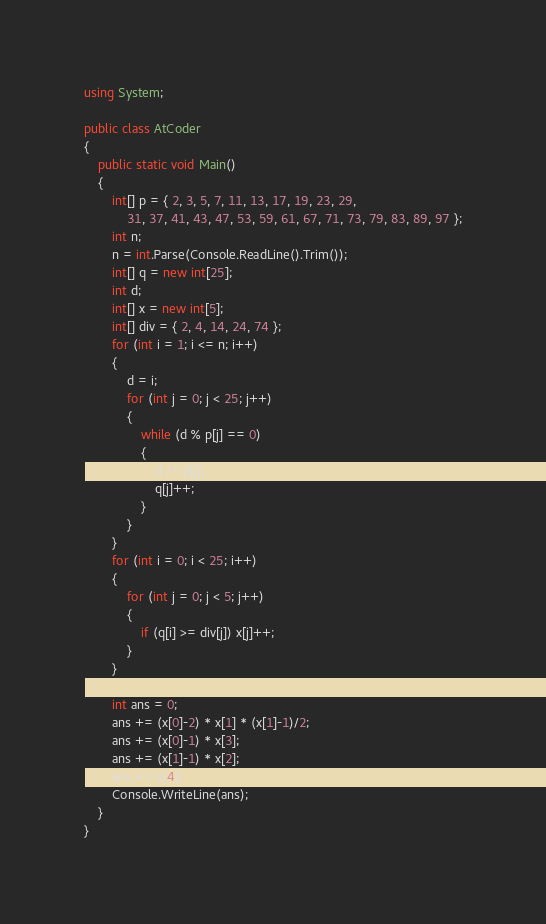<code> <loc_0><loc_0><loc_500><loc_500><_C#_>using System;

public class AtCoder
{
    public static void Main()
    {
        int[] p = { 2, 3, 5, 7, 11, 13, 17, 19, 23, 29,
            31, 37, 41, 43, 47, 53, 59, 61, 67, 71, 73, 79, 83, 89, 97 };
        int n;
        n = int.Parse(Console.ReadLine().Trim());
        int[] q = new int[25];
        int d;
        int[] x = new int[5];
        int[] div = { 2, 4, 14, 24, 74 };
        for (int i = 1; i <= n; i++)
        {
            d = i;
            for (int j = 0; j < 25; j++)
            {
                while (d % p[j] == 0)
                {
                    d /= p[j];
                    q[j]++;
                }
            }
        }
        for (int i = 0; i < 25; i++)
        {
            for (int j = 0; j < 5; j++)
            {
                if (q[i] >= div[j]) x[j]++;
            }        
        }

        int ans = 0;
        ans += (x[0]-2) * x[1] * (x[1]-1)/2;
        ans += (x[0]-1) * x[3];
        ans += (x[1]-1) * x[2];
        ans += x[4];
        Console.WriteLine(ans);
    }
}
</code> 